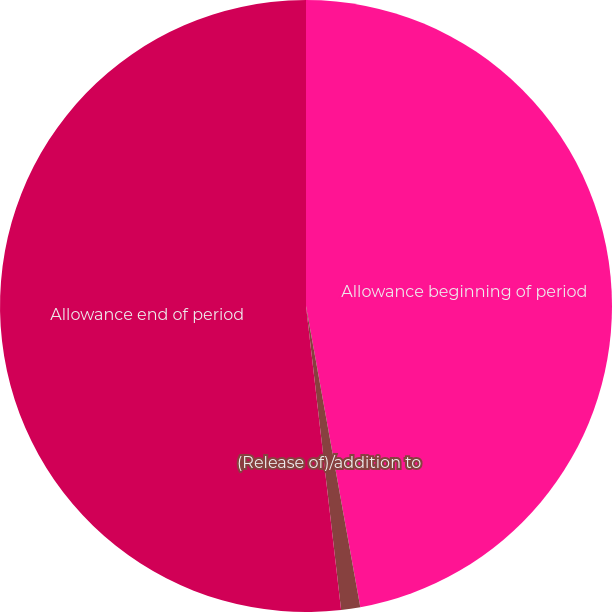<chart> <loc_0><loc_0><loc_500><loc_500><pie_chart><fcel>Allowance beginning of period<fcel>(Release of)/addition to<fcel>Allowance end of period<nl><fcel>47.16%<fcel>1.01%<fcel>51.83%<nl></chart> 